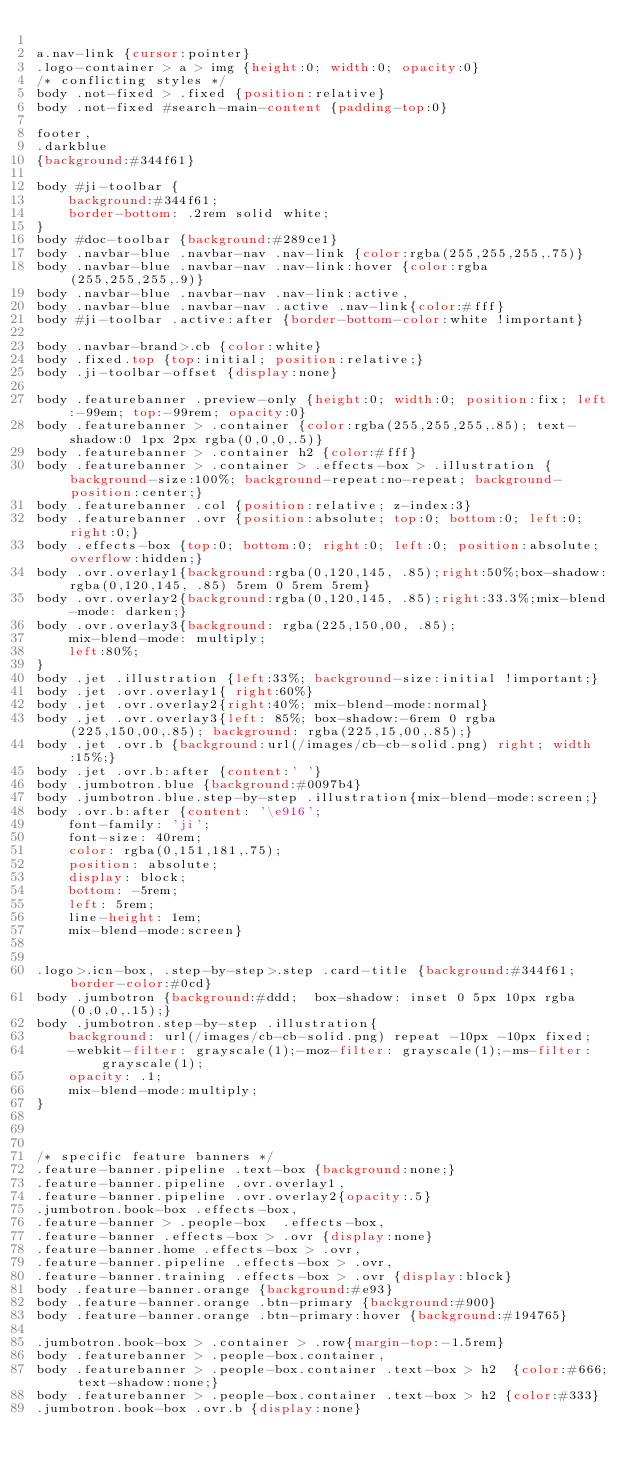Convert code to text. <code><loc_0><loc_0><loc_500><loc_500><_CSS_>
a.nav-link {cursor:pointer}
.logo-container > a > img {height:0; width:0; opacity:0}
/* conflicting styles */
body .not-fixed > .fixed {position:relative}
body .not-fixed #search-main-content {padding-top:0}

footer,
.darkblue
{background:#344f61}

body #ji-toolbar {
    background:#344f61;
    border-bottom: .2rem solid white;
}
body #doc-toolbar {background:#289ce1}
body .navbar-blue .navbar-nav .nav-link {color:rgba(255,255,255,.75)}
body .navbar-blue .navbar-nav .nav-link:hover {color:rgba(255,255,255,.9)}
body .navbar-blue .navbar-nav .nav-link:active,
body .navbar-blue .navbar-nav .active .nav-link{color:#fff}
body #ji-toolbar .active:after {border-bottom-color:white !important}

body .navbar-brand>.cb {color:white}
body .fixed.top {top:initial; position:relative;}
body .ji-toolbar-offset {display:none}

body .featurebanner .preview-only {height:0; width:0; position:fix; left:-99em; top:-99rem; opacity:0}
body .featurebanner > .container {color:rgba(255,255,255,.85); text-shadow:0 1px 2px rgba(0,0,0,.5)}
body .featurebanner > .container h2 {color:#fff}
body .featurebanner > .container > .effects-box > .illustration {background-size:100%; background-repeat:no-repeat; background-position:center;}
body .featurebanner .col {position:relative; z-index:3}
body .featurebanner .ovr {position:absolute; top:0; bottom:0; left:0; right:0;}
body .effects-box {top:0; bottom:0; right:0; left:0; position:absolute; overflow:hidden;}
body .ovr.overlay1{background:rgba(0,120,145, .85);right:50%;box-shadow:rgba(0,120,145, .85) 5rem 0 5rem 5rem}
body .ovr.overlay2{background:rgba(0,120,145, .85);right:33.3%;mix-blend-mode: darken;}
body .ovr.overlay3{background: rgba(225,150,00, .85);
    mix-blend-mode: multiply;
    left:80%;
}
body .jet .illustration {left:33%; background-size:initial !important;}
body .jet .ovr.overlay1{ right:60%}
body .jet .ovr.overlay2{right:40%; mix-blend-mode:normal}
body .jet .ovr.overlay3{left: 85%; box-shadow:-6rem 0 rgba(225,150,00,.85); background: rgba(225,15,00,.85);}
body .jet .ovr.b {background:url(/images/cb-cb-solid.png) right; width:15%;}
body .jet .ovr.b:after {content:' '}
body .jumbotron.blue {background:#0097b4}
body .jumbotron.blue.step-by-step .illustration{mix-blend-mode:screen;}
body .ovr.b:after {content: '\e916';
    font-family: 'ji';
    font-size: 40rem;
    color: rgba(0,151,181,.75);
    position: absolute;
    display: block;
    bottom: -5rem;
    left: 5rem;
    line-height: 1em;
    mix-blend-mode:screen}


.logo>.icn-box, .step-by-step>.step .card-title {background:#344f61; border-color:#0cd}
body .jumbotron {background:#ddd;  box-shadow: inset 0 5px 10px rgba(0,0,0,.15);}
body .jumbotron.step-by-step .illustration{
    background: url(/images/cb-cb-solid.png) repeat -10px -10px fixed;
    -webkit-filter: grayscale(1);-moz-filter: grayscale(1);-ms-filter: grayscale(1);
    opacity: .1;
    mix-blend-mode:multiply;
}



/* specific feature banners */
.feature-banner.pipeline .text-box {background:none;}
.feature-banner.pipeline .ovr.overlay1,
.feature-banner.pipeline .ovr.overlay2{opacity:.5}
.jumbotron.book-box .effects-box,
.feature-banner > .people-box  .effects-box,
.feature-banner .effects-box > .ovr {display:none}
.feature-banner.home .effects-box > .ovr,
.feature-banner.pipeline .effects-box > .ovr,
.feature-banner.training .effects-box > .ovr {display:block}
body .feature-banner.orange {background:#e93}
body .feature-banner.orange .btn-primary {background:#900}
body .feature-banner.orange .btn-primary:hover {background:#194765}

.jumbotron.book-box > .container > .row{margin-top:-1.5rem}
body .featurebanner > .people-box.container,
body .featurebanner > .people-box.container .text-box > h2  {color:#666; text-shadow:none;}
body .featurebanner > .people-box.container .text-box > h2 {color:#333}
.jumbotron.book-box .ovr.b {display:none}
</code> 